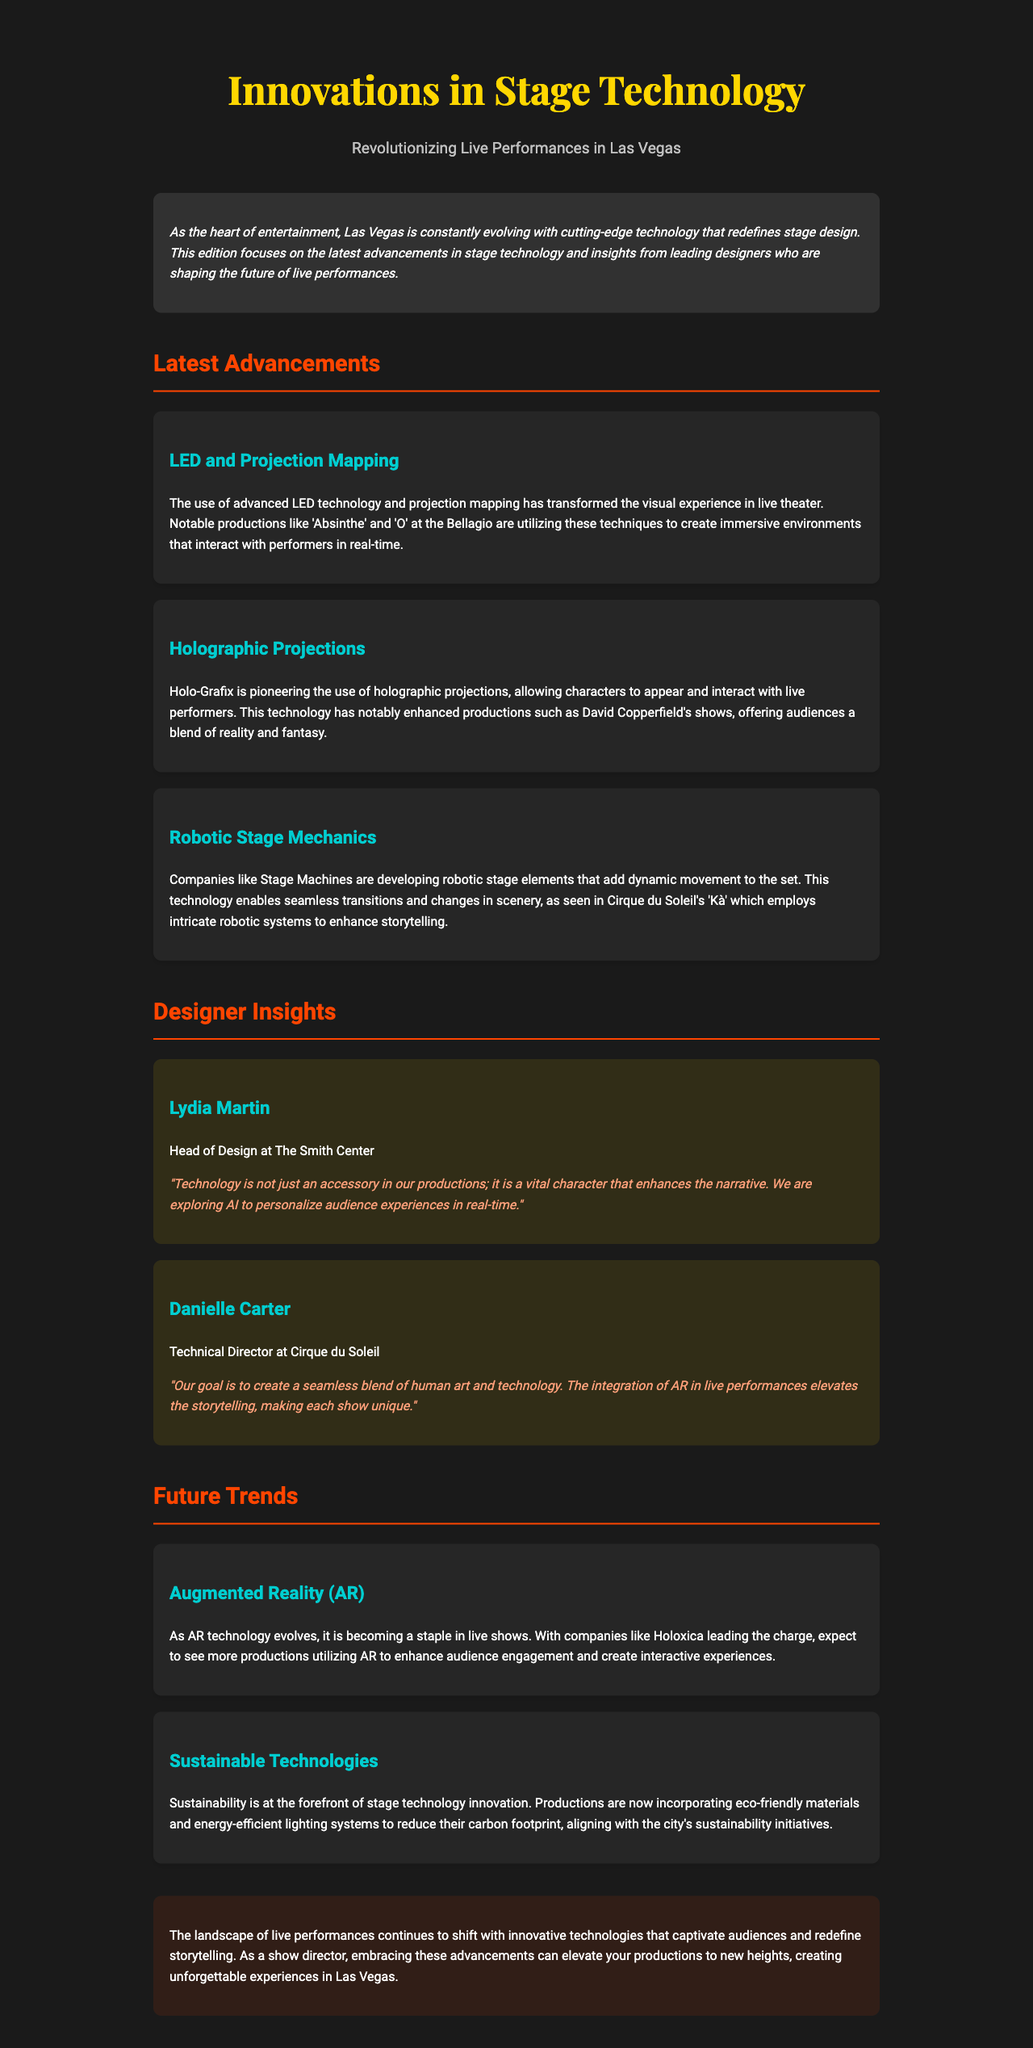What is the title of the newsletter? The title of the newsletter is prominently displayed at the top of the document.
Answer: Innovations in Stage Technology Who is the Head of Design at The Smith Center? The document contains an interview section highlighting key designers, including the Head of Design.
Answer: Lydia Martin What production uses advanced LED technology and projection mapping? The newsletter mentions notable productions that utilize this technology for immersive experiences.
Answer: Absinthe Which technology is being explored to personalize audience experiences in real-time? The insights section discusses the exploration of specific technologies to enhance audience interaction.
Answer: AI What does Danielle Carter describe as a goal in their productions? The document quotes a designer discussing the integration of art and technology in their approach.
Answer: A seamless blend of human art and technology Which company is pioneering holographic projections? The document specifically names a company that is leading in this technology area.
Answer: Holo-Grafix What sustainable initiative is highlighted in the document? The newsletter discusses the incorporation of specific technologies aimed at reducing environmental impact.
Answer: Eco-friendly materials What is a future trend mentioned that enhances audience engagement? The document forecasts the evolution of certain technologies that improve interaction with audiences.
Answer: Augmented Reality (AR) 